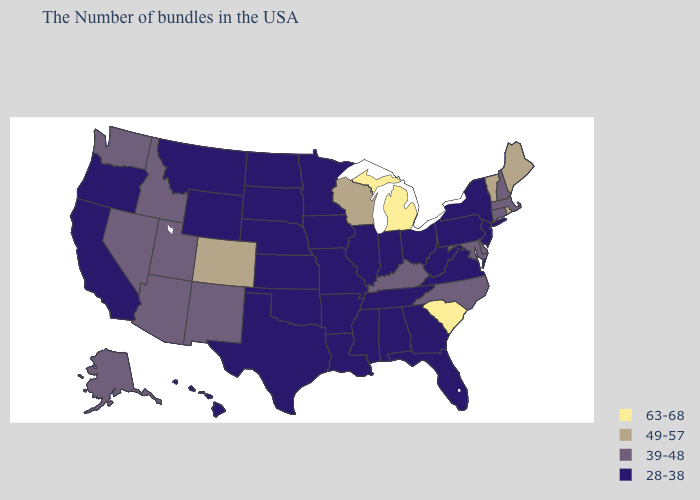Name the states that have a value in the range 63-68?
Give a very brief answer. South Carolina, Michigan. What is the value of Alabama?
Answer briefly. 28-38. Which states have the highest value in the USA?
Answer briefly. South Carolina, Michigan. What is the highest value in the South ?
Quick response, please. 63-68. Name the states that have a value in the range 49-57?
Be succinct. Maine, Rhode Island, Vermont, Wisconsin, Colorado. What is the highest value in the MidWest ?
Concise answer only. 63-68. Does Mississippi have the same value as Colorado?
Quick response, please. No. Does California have the highest value in the West?
Be succinct. No. Among the states that border Massachusetts , which have the lowest value?
Be succinct. New York. What is the value of South Carolina?
Concise answer only. 63-68. Among the states that border Connecticut , which have the lowest value?
Quick response, please. New York. Name the states that have a value in the range 39-48?
Answer briefly. Massachusetts, New Hampshire, Connecticut, Delaware, Maryland, North Carolina, Kentucky, New Mexico, Utah, Arizona, Idaho, Nevada, Washington, Alaska. What is the highest value in states that border Nebraska?
Quick response, please. 49-57. Does Michigan have the highest value in the MidWest?
Give a very brief answer. Yes. 